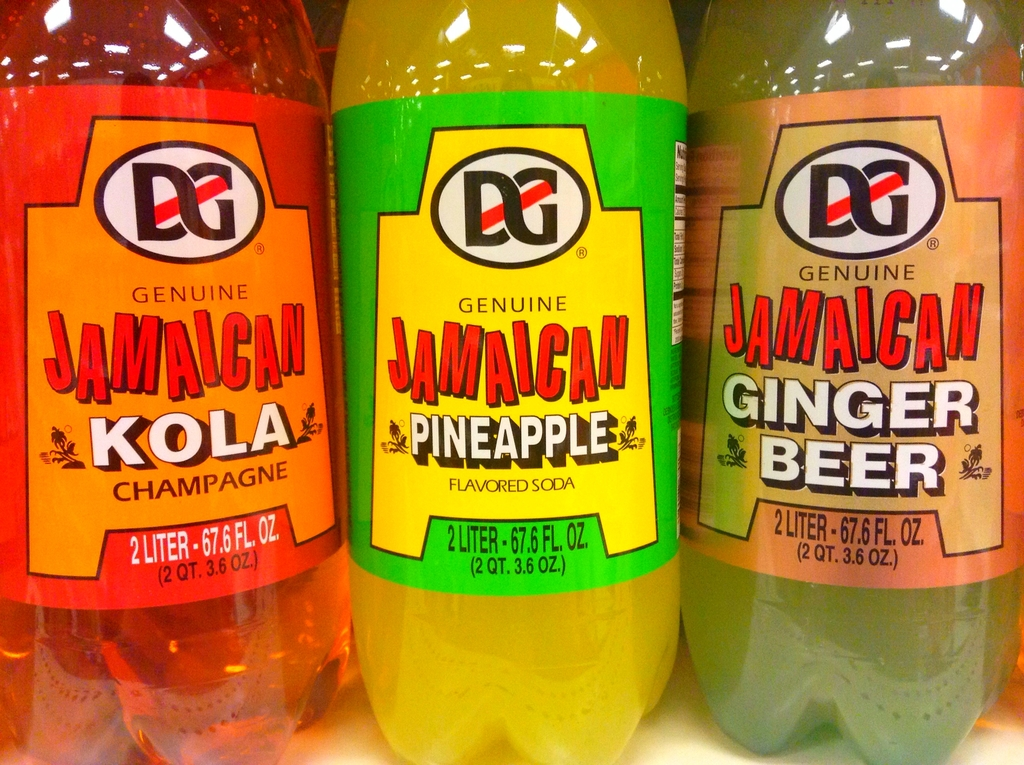Which of the beverages shown would likely be the sweetest and why? The Pineapple flavored soda is likely the sweetest of the three because fruit-flavored sodas generally contain more sugars to enhance the fruitiness compared to other flavors like Kola Champagne or Ginger Beer. 